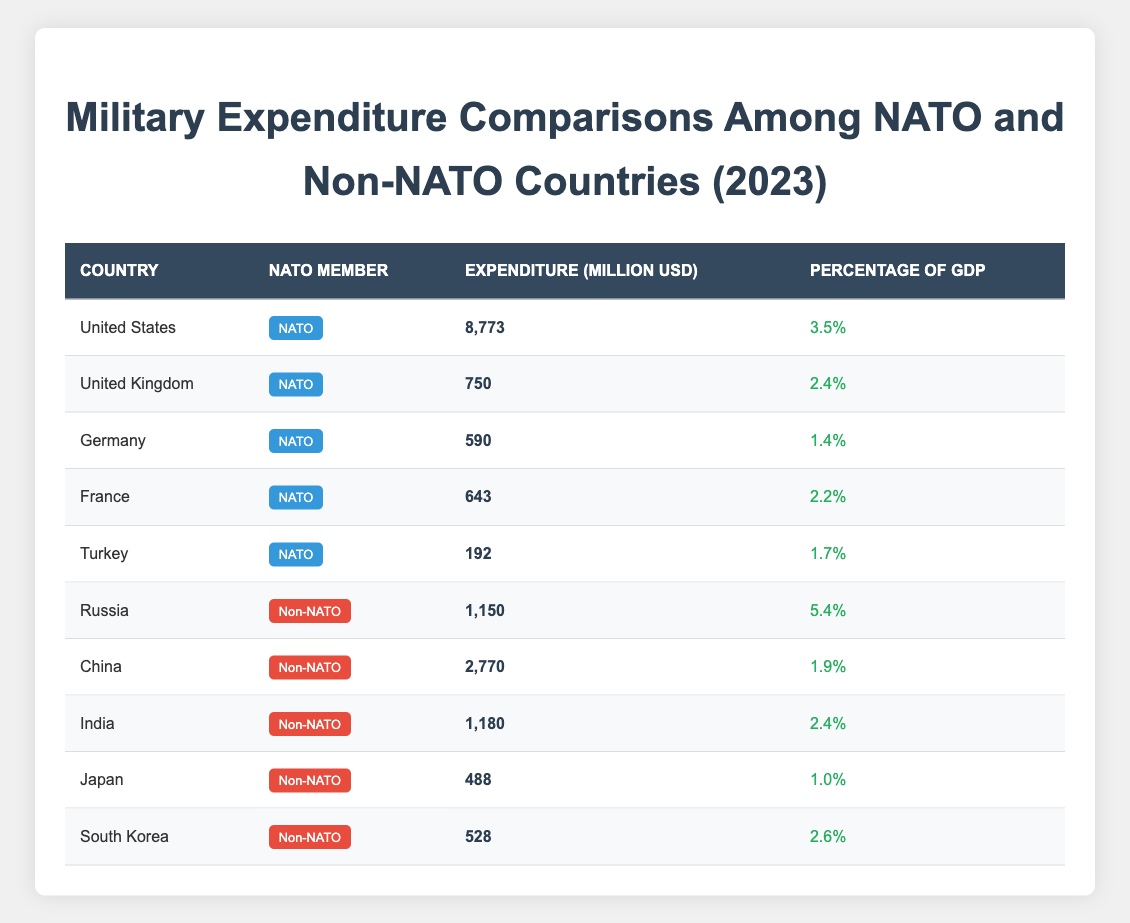What is the military expenditure of the United States? The United States military expenditure is listed in the table as 8,773 million USD.
Answer: 8,773 million USD Which NATO member has the lowest military expenditure? The table shows that Turkey, a NATO member, has the lowest military expenditure at 192 million USD.
Answer: Turkey Is Russia a NATO member? The table indicates that Russia is classified as a non-NATO country.
Answer: No What is the total military expenditure of all NATO members combined? Adding the expenditures of the NATO members: 8,773 (US) + 750 (UK) + 590 (Germany) + 643 (France) + 192 (Turkey) equals 10,948 million USD.
Answer: 10,948 million USD Which country has the highest percentage of GDP spent on military among non-NATO countries? Among the non-NATO countries, Russia has the highest percentage of GDP spent on military at 5.4%.
Answer: Russia How much more does the United States spend on military than China? The United States spends 8,773 million USD, while China spends 2,770 million USD. The difference is 8,773 - 2,770 = 6,003 million USD.
Answer: 6,003 million USD What is the average military expenditure of NATO countries listed in the table? The total military expenditure for NATO countries is 10,948 million USD, and there are 5 NATO countries listed, so the average is 10,948/5 = 2,189.6 million USD.
Answer: 2,189.6 million USD Does Japan have a higher military expenditure than South Korea? Comparing their expenditures: Japan has 488 million USD, while South Korea has 528 million USD. South Korea has a higher expenditure.
Answer: No Which country has a higher percentage of GDP spent on military, India or the United Kingdom? Looking at the table, India spends 2.4% of its GDP on military, whereas the UK spends 2.4% as well. Therefore, they spend the same percentage of GDP.
Answer: They are the same 